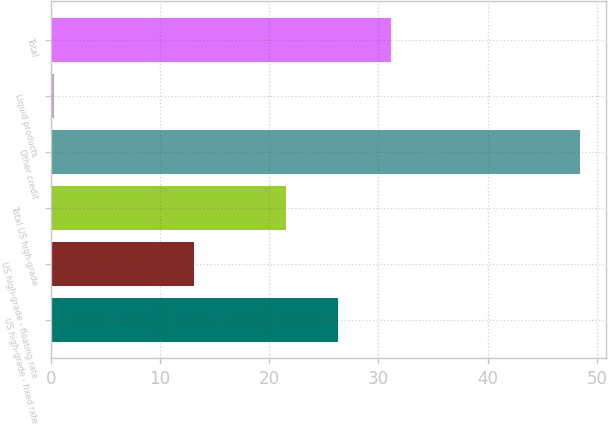<chart> <loc_0><loc_0><loc_500><loc_500><bar_chart><fcel>US high-grade - fixed rate<fcel>US high-grade - floating rate<fcel>Total US high-grade<fcel>Other credit<fcel>Liquid products<fcel>Total<nl><fcel>26.31<fcel>13.1<fcel>21.5<fcel>48.4<fcel>0.3<fcel>31.12<nl></chart> 